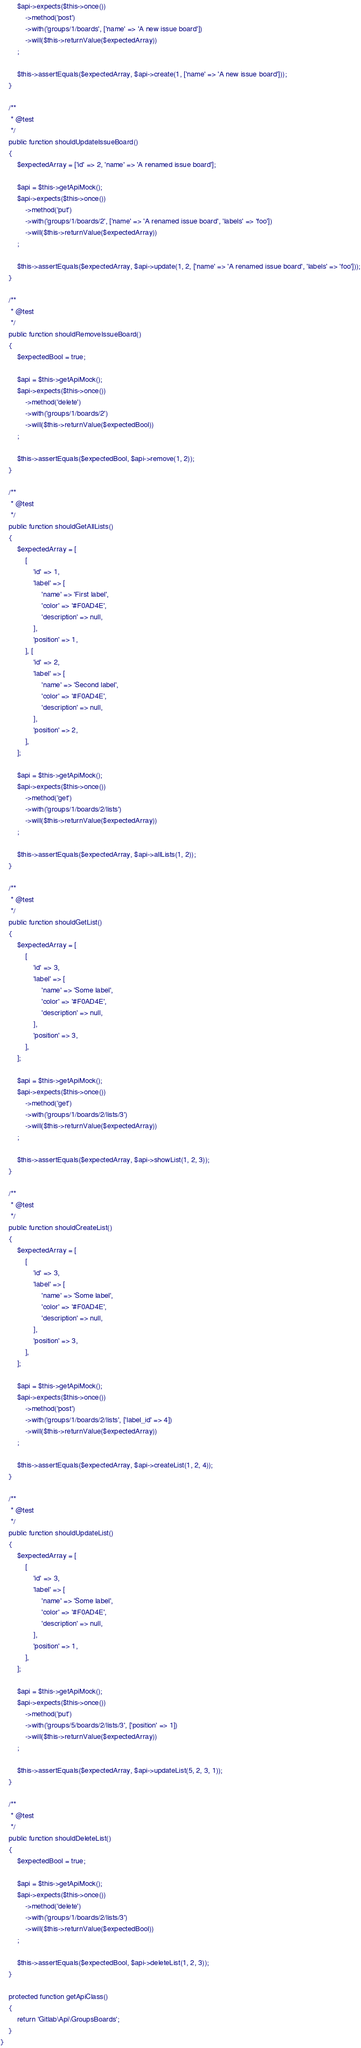Convert code to text. <code><loc_0><loc_0><loc_500><loc_500><_PHP_>        $api->expects($this->once())
            ->method('post')
            ->with('groups/1/boards', ['name' => 'A new issue board'])
            ->will($this->returnValue($expectedArray))
        ;

        $this->assertEquals($expectedArray, $api->create(1, ['name' => 'A new issue board']));
    }

    /**
     * @test
     */
    public function shouldUpdateIssueBoard()
    {
        $expectedArray = ['id' => 2, 'name' => 'A renamed issue board'];

        $api = $this->getApiMock();
        $api->expects($this->once())
            ->method('put')
            ->with('groups/1/boards/2', ['name' => 'A renamed issue board', 'labels' => 'foo'])
            ->will($this->returnValue($expectedArray))
        ;

        $this->assertEquals($expectedArray, $api->update(1, 2, ['name' => 'A renamed issue board', 'labels' => 'foo']));
    }

    /**
     * @test
     */
    public function shouldRemoveIssueBoard()
    {
        $expectedBool = true;

        $api = $this->getApiMock();
        $api->expects($this->once())
            ->method('delete')
            ->with('groups/1/boards/2')
            ->will($this->returnValue($expectedBool))
        ;

        $this->assertEquals($expectedBool, $api->remove(1, 2));
    }

    /**
     * @test
     */
    public function shouldGetAllLists()
    {
        $expectedArray = [
            [
                'id' => 1,
                'label' => [
                    'name' => 'First label',
                    'color' => '#F0AD4E',
                    'description' => null,
                ],
                'position' => 1,
            ], [
                'id' => 2,
                'label' => [
                    'name' => 'Second label',
                    'color' => '#F0AD4E',
                    'description' => null,
                ],
                'position' => 2,
            ],
        ];

        $api = $this->getApiMock();
        $api->expects($this->once())
            ->method('get')
            ->with('groups/1/boards/2/lists')
            ->will($this->returnValue($expectedArray))
        ;

        $this->assertEquals($expectedArray, $api->allLists(1, 2));
    }

    /**
     * @test
     */
    public function shouldGetList()
    {
        $expectedArray = [
            [
                'id' => 3,
                'label' => [
                    'name' => 'Some label',
                    'color' => '#F0AD4E',
                    'description' => null,
                ],
                'position' => 3,
            ],
        ];

        $api = $this->getApiMock();
        $api->expects($this->once())
            ->method('get')
            ->with('groups/1/boards/2/lists/3')
            ->will($this->returnValue($expectedArray))
        ;

        $this->assertEquals($expectedArray, $api->showList(1, 2, 3));
    }

    /**
     * @test
     */
    public function shouldCreateList()
    {
        $expectedArray = [
            [
                'id' => 3,
                'label' => [
                    'name' => 'Some label',
                    'color' => '#F0AD4E',
                    'description' => null,
                ],
                'position' => 3,
            ],
        ];

        $api = $this->getApiMock();
        $api->expects($this->once())
            ->method('post')
            ->with('groups/1/boards/2/lists', ['label_id' => 4])
            ->will($this->returnValue($expectedArray))
        ;

        $this->assertEquals($expectedArray, $api->createList(1, 2, 4));
    }

    /**
     * @test
     */
    public function shouldUpdateList()
    {
        $expectedArray = [
            [
                'id' => 3,
                'label' => [
                    'name' => 'Some label',
                    'color' => '#F0AD4E',
                    'description' => null,
                ],
                'position' => 1,
            ],
        ];

        $api = $this->getApiMock();
        $api->expects($this->once())
            ->method('put')
            ->with('groups/5/boards/2/lists/3', ['position' => 1])
            ->will($this->returnValue($expectedArray))
        ;

        $this->assertEquals($expectedArray, $api->updateList(5, 2, 3, 1));
    }

    /**
     * @test
     */
    public function shouldDeleteList()
    {
        $expectedBool = true;

        $api = $this->getApiMock();
        $api->expects($this->once())
            ->method('delete')
            ->with('groups/1/boards/2/lists/3')
            ->will($this->returnValue($expectedBool))
        ;

        $this->assertEquals($expectedBool, $api->deleteList(1, 2, 3));
    }

    protected function getApiClass()
    {
        return 'Gitlab\Api\GroupsBoards';
    }
}
</code> 